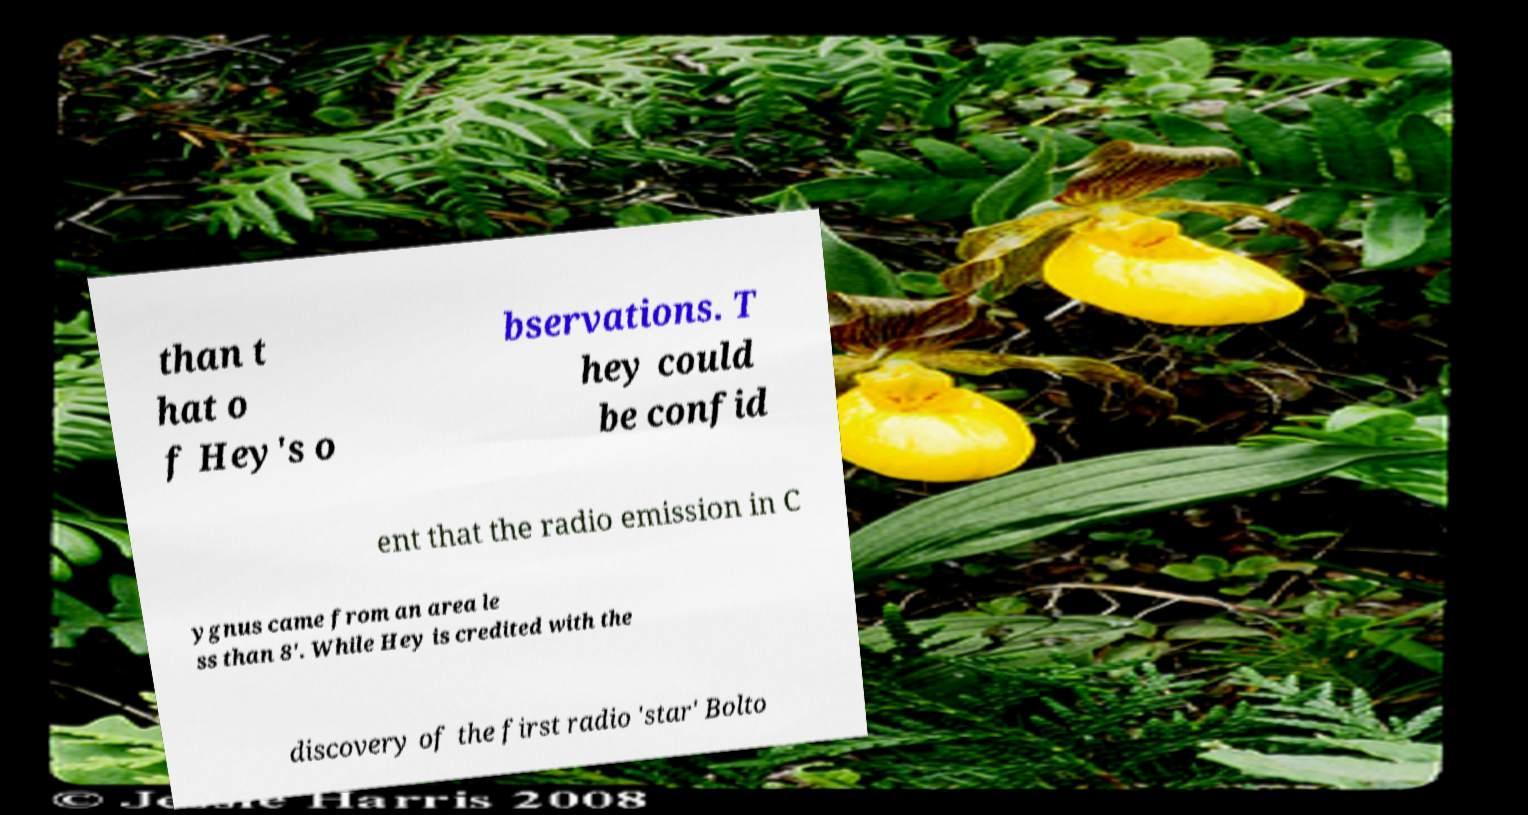Please identify and transcribe the text found in this image. than t hat o f Hey's o bservations. T hey could be confid ent that the radio emission in C ygnus came from an area le ss than 8'. While Hey is credited with the discovery of the first radio 'star' Bolto 